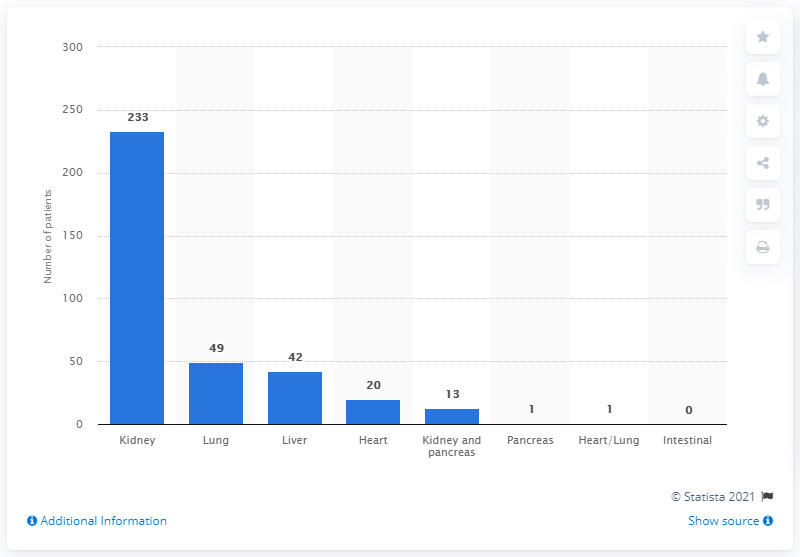Indicate a few pertinent items in this graphic. During the 2019/2020 fiscal year, it was reported that 233 patients in the UK died while waiting for a kidney transplant. 